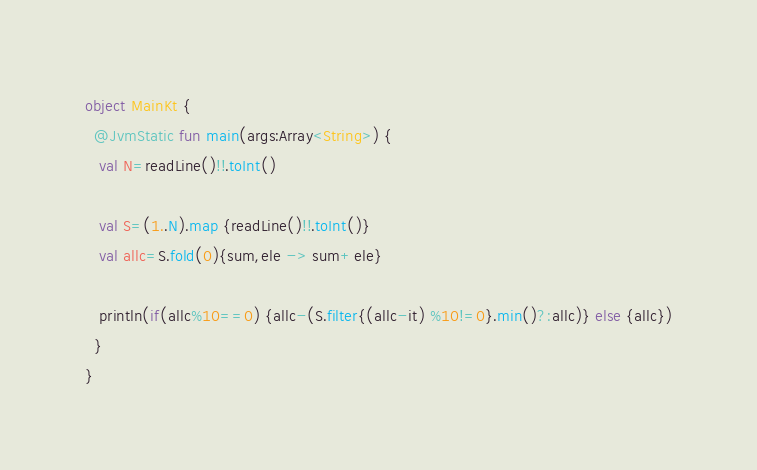Convert code to text. <code><loc_0><loc_0><loc_500><loc_500><_Kotlin_>
object MainKt {
  @JvmStatic fun main(args:Array<String>) {
   val N=readLine()!!.toInt()

   val S=(1..N).map {readLine()!!.toInt()}
   val allc=S.fold(0){sum,ele -> sum+ele}

   println(if(allc%10==0) {allc-(S.filter{(allc-it) %10!=0}.min()?:allc)} else {allc})
  }
}
</code> 